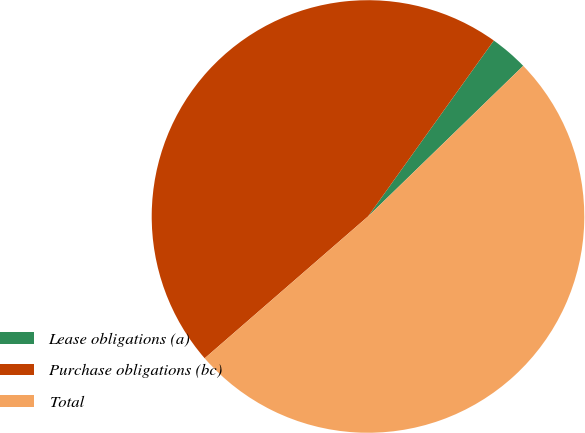<chart> <loc_0><loc_0><loc_500><loc_500><pie_chart><fcel>Lease obligations (a)<fcel>Purchase obligations (bc)<fcel>Total<nl><fcel>2.86%<fcel>46.26%<fcel>50.88%<nl></chart> 